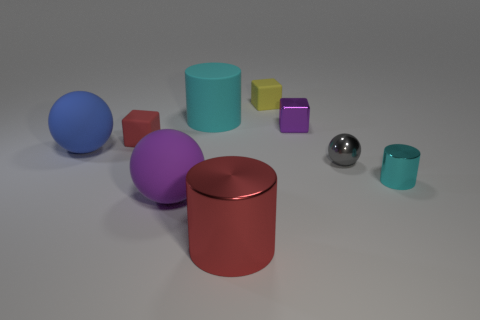Subtract 1 cylinders. How many cylinders are left? 2 Add 1 small purple metal things. How many objects exist? 10 Subtract all blocks. How many objects are left? 6 Add 7 yellow blocks. How many yellow blocks exist? 8 Subtract 1 yellow cubes. How many objects are left? 8 Subtract all gray things. Subtract all small cyan matte spheres. How many objects are left? 8 Add 9 small red matte cubes. How many small red matte cubes are left? 10 